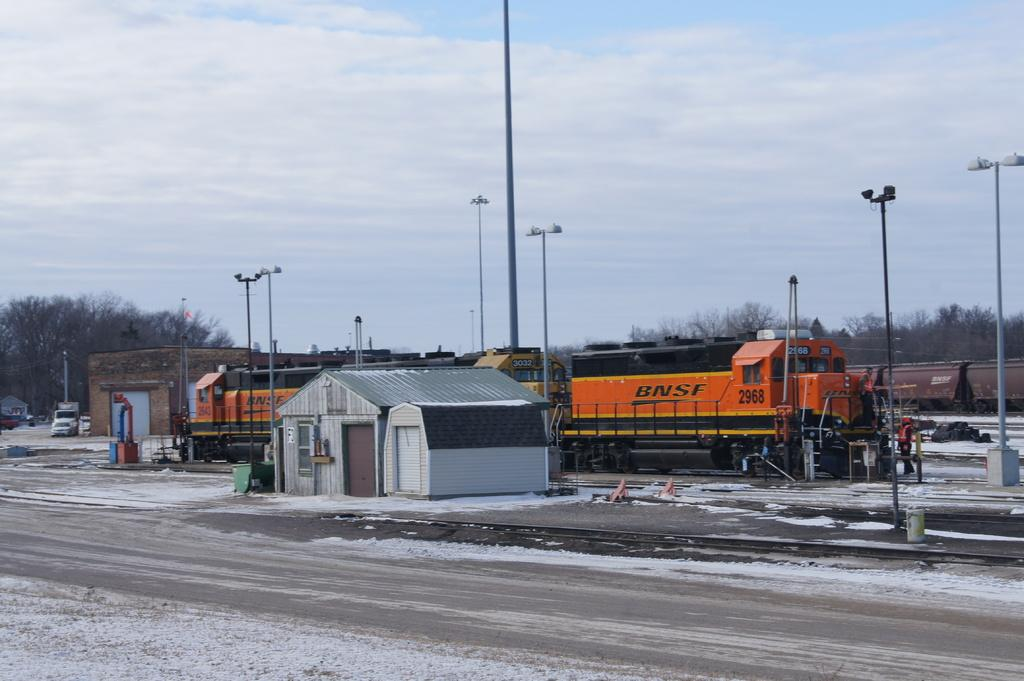<image>
Give a short and clear explanation of the subsequent image. A BNSF freight train sits in a snowy train yard. 